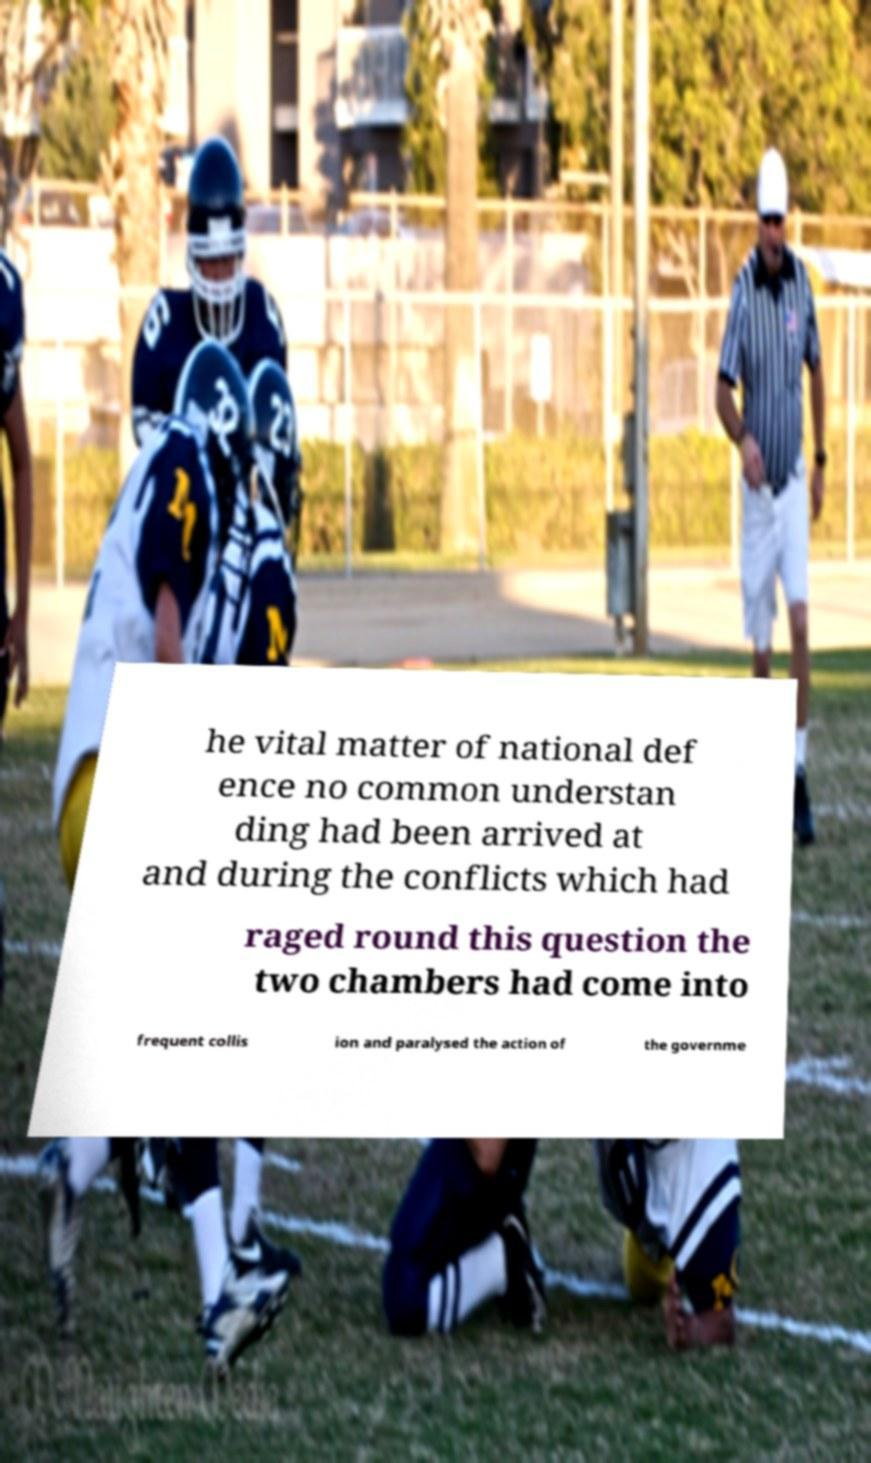Could you assist in decoding the text presented in this image and type it out clearly? he vital matter of national def ence no common understan ding had been arrived at and during the conflicts which had raged round this question the two chambers had come into frequent collis ion and paralysed the action of the governme 